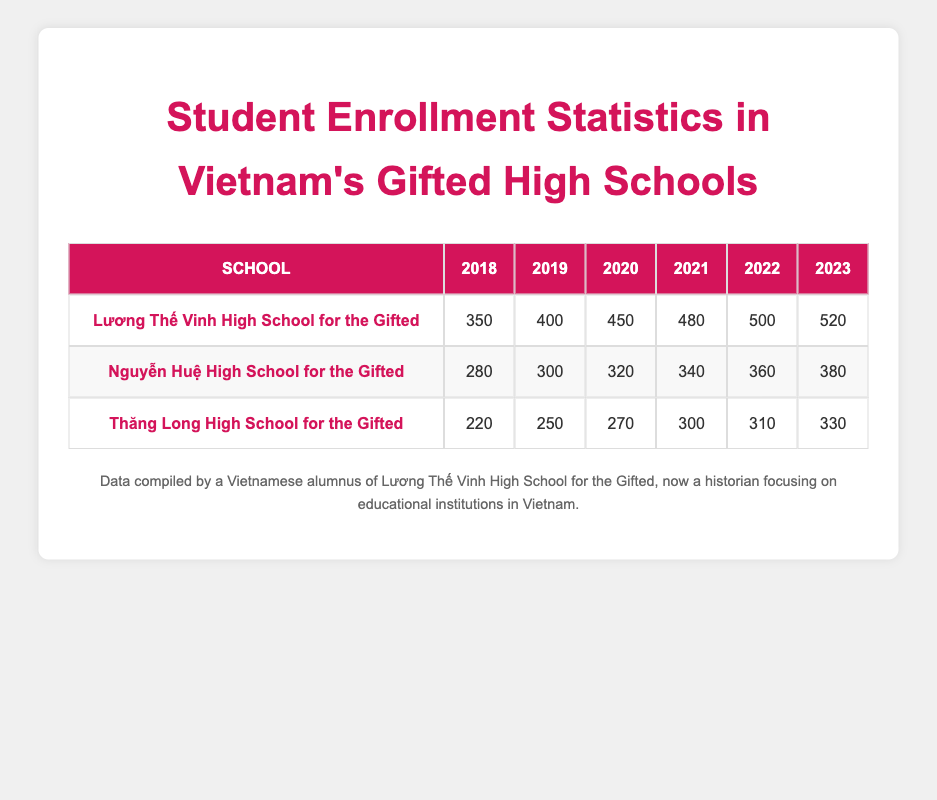What was the enrollment at Lương Thế Vinh High School for the Gifted in 2020? The table shows that Lương Thế Vinh High School for the Gifted had an enrollment of 450 students in the year 2020.
Answer: 450 Which school had the highest enrollment in 2021? By looking at the enrollment numbers for each school in 2021, Lương Thế Vinh High School for the Gifted had the highest enrollment with 480 students compared to the other two schools.
Answer: Lương Thế Vinh High School for the Gifted What is the total enrollment of Nguyễn Huệ High School for the Gifted from 2018 to 2023? To find the total enrollment for Nguyễn Huệ High School for the Gifted, we add the enrollments from each year: 280 + 300 + 320 + 340 + 360 + 380 = 1980.
Answer: 1980 Did Thăng Long High School for the Gifted experience an increase in enrollment every year from 2018 to 2023? By examining the enrollments: 220 (2018), 250 (2019), 270 (2020), 300 (2021), 310 (2022), and 330 (2023), we see that there is a consistent increase each year, so the statement is true.
Answer: Yes What was the average enrollment at Lương Thế Vinh High School for the Gifted from 2018 to 2023? The enrollment values for Lương Thế Vinh High School across the years are 350, 400, 450, 480, 500, and 520. Summing these gives: 350 + 400 + 450 + 480 + 500 + 520 = 3180. Since there are 6 years, the average is 3180 / 6 = 530.
Answer: 530 What is the change in enrollment for Nguyễn Huệ High School for the Gifted from 2018 to 2023? The enrollment in 2018 was 280 and in 2023 it was 380. The change is calculated as 380 - 280 = 100, indicating an increase over the five years.
Answer: 100 Did Lương Thế Vinh High School for the Gifted have an enrollment of over 500 students in 2022 and 2023? The enrollments for these years are 500 in 2022 and 520 in 2023, which confirms that both years had an enrollment over 500.
Answer: Yes What was the total enrollment across all the schools in 2022? To find the total for 2022, we sum the enrollments: Lương Thế Vinh (500) + Nguyễn Huệ (360) + Thăng Long (310) = 1170.
Answer: 1170 